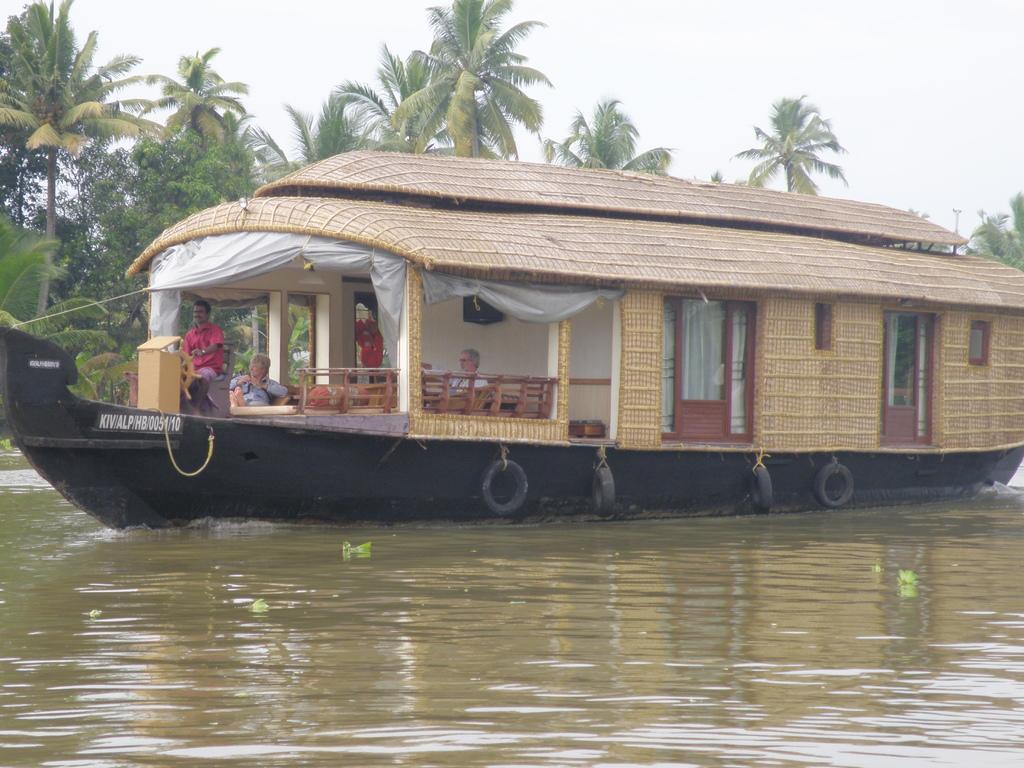Could you give a brief overview of what you see in this image? In the foreground of this image, there is a boat on the surface of the water in which two persons are sitting. In the background, there are trees and the sky. 